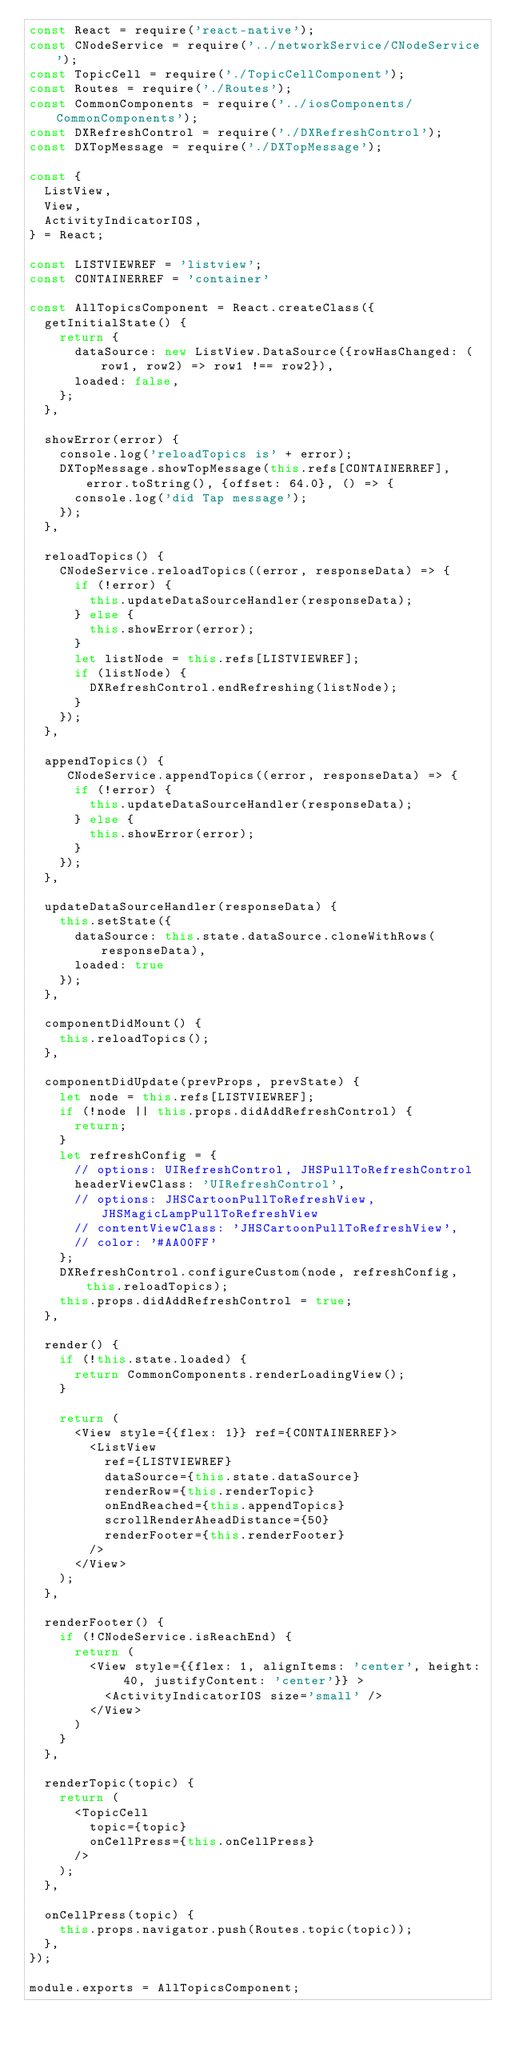<code> <loc_0><loc_0><loc_500><loc_500><_JavaScript_>const React = require('react-native');
const CNodeService = require('../networkService/CNodeService');
const TopicCell = require('./TopicCellComponent');
const Routes = require('./Routes');
const CommonComponents = require('../iosComponents/CommonComponents');
const DXRefreshControl = require('./DXRefreshControl');
const DXTopMessage = require('./DXTopMessage');

const {
  ListView,
  View,
  ActivityIndicatorIOS,
} = React;

const LISTVIEWREF = 'listview';
const CONTAINERREF = 'container'

const AllTopicsComponent = React.createClass({
  getInitialState() {
    return {
      dataSource: new ListView.DataSource({rowHasChanged: (row1, row2) => row1 !== row2}),
      loaded: false,
    };
  },

  showError(error) {
    console.log('reloadTopics is' + error);
    DXTopMessage.showTopMessage(this.refs[CONTAINERREF], error.toString(), {offset: 64.0}, () => {
      console.log('did Tap message');
    });
  },

  reloadTopics() {
    CNodeService.reloadTopics((error, responseData) => {
      if (!error) {
        this.updateDataSourceHandler(responseData);
      } else {
        this.showError(error);
      }
      let listNode = this.refs[LISTVIEWREF];
      if (listNode) {
        DXRefreshControl.endRefreshing(listNode);
      }
    });
  },

  appendTopics() {
     CNodeService.appendTopics((error, responseData) => {
      if (!error) {
        this.updateDataSourceHandler(responseData);
      } else {
        this.showError(error);
      }
    });
  },

  updateDataSourceHandler(responseData) {
    this.setState({
      dataSource: this.state.dataSource.cloneWithRows(responseData),
      loaded: true
    });
  },

  componentDidMount() {
    this.reloadTopics();
  },

  componentDidUpdate(prevProps, prevState) {
    let node = this.refs[LISTVIEWREF];
    if (!node || this.props.didAddRefreshControl) {
      return;
    }
    let refreshConfig = {
      // options: UIRefreshControl, JHSPullToRefreshControl
      headerViewClass: 'UIRefreshControl',
      // options: JHSCartoonPullToRefreshView, JHSMagicLampPullToRefreshView
      // contentViewClass: 'JHSCartoonPullToRefreshView',
      // color: '#AA00FF'
    };
    DXRefreshControl.configureCustom(node, refreshConfig, this.reloadTopics);
    this.props.didAddRefreshControl = true;
  },

  render() {
    if (!this.state.loaded) {
      return CommonComponents.renderLoadingView();
    }

    return (
      <View style={{flex: 1}} ref={CONTAINERREF}>
        <ListView
          ref={LISTVIEWREF}
          dataSource={this.state.dataSource}
          renderRow={this.renderTopic}
          onEndReached={this.appendTopics}
          scrollRenderAheadDistance={50}
          renderFooter={this.renderFooter}
        />
      </View>
    );
  },

  renderFooter() {
    if (!CNodeService.isReachEnd) {
      return (
        <View style={{flex: 1, alignItems: 'center', height: 40, justifyContent: 'center'}} >
          <ActivityIndicatorIOS size='small' />
        </View>
      )
    }
  },

  renderTopic(topic) {
    return (
      <TopicCell
        topic={topic}
        onCellPress={this.onCellPress}
      />
    );
  },

  onCellPress(topic) {
    this.props.navigator.push(Routes.topic(topic));
  },
});

module.exports = AllTopicsComponent;
</code> 